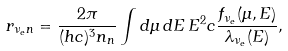Convert formula to latex. <formula><loc_0><loc_0><loc_500><loc_500>r _ { \nu _ { e } n } = \frac { 2 \pi } { ( h c ) ^ { 3 } n _ { n } } \int d \mu \, d E \, E ^ { 2 } c \frac { f _ { \nu _ { e } } ( \mu , E ) } { \lambda _ { \nu _ { e } } ( E ) } ,</formula> 